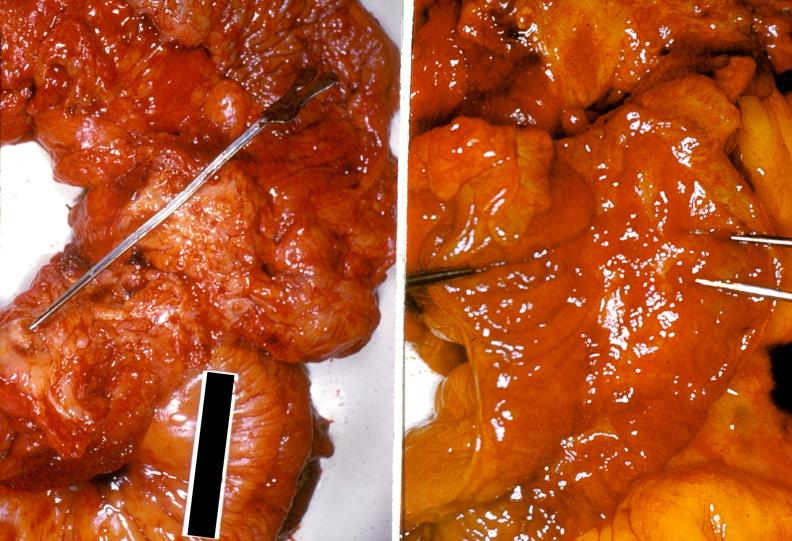s mucinous cystadenocarcinoma present?
Answer the question using a single word or phrase. No 